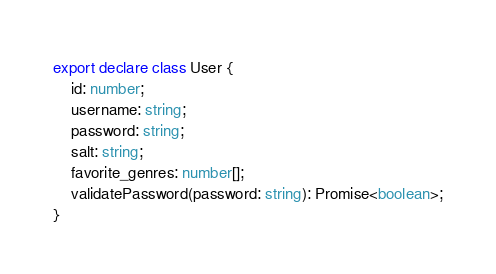Convert code to text. <code><loc_0><loc_0><loc_500><loc_500><_TypeScript_>export declare class User {
    id: number;
    username: string;
    password: string;
    salt: string;
    favorite_genres: number[];
    validatePassword(password: string): Promise<boolean>;
}
</code> 